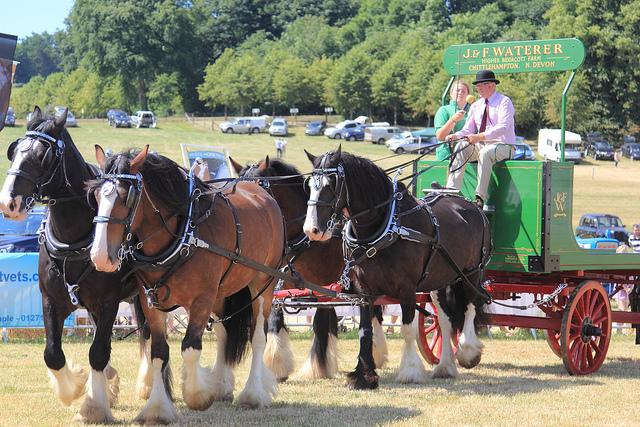What is the guy wearing a black hat doing? Please explain your reasoning. talking. The guy in the black hat is speaking to the man next to him. 